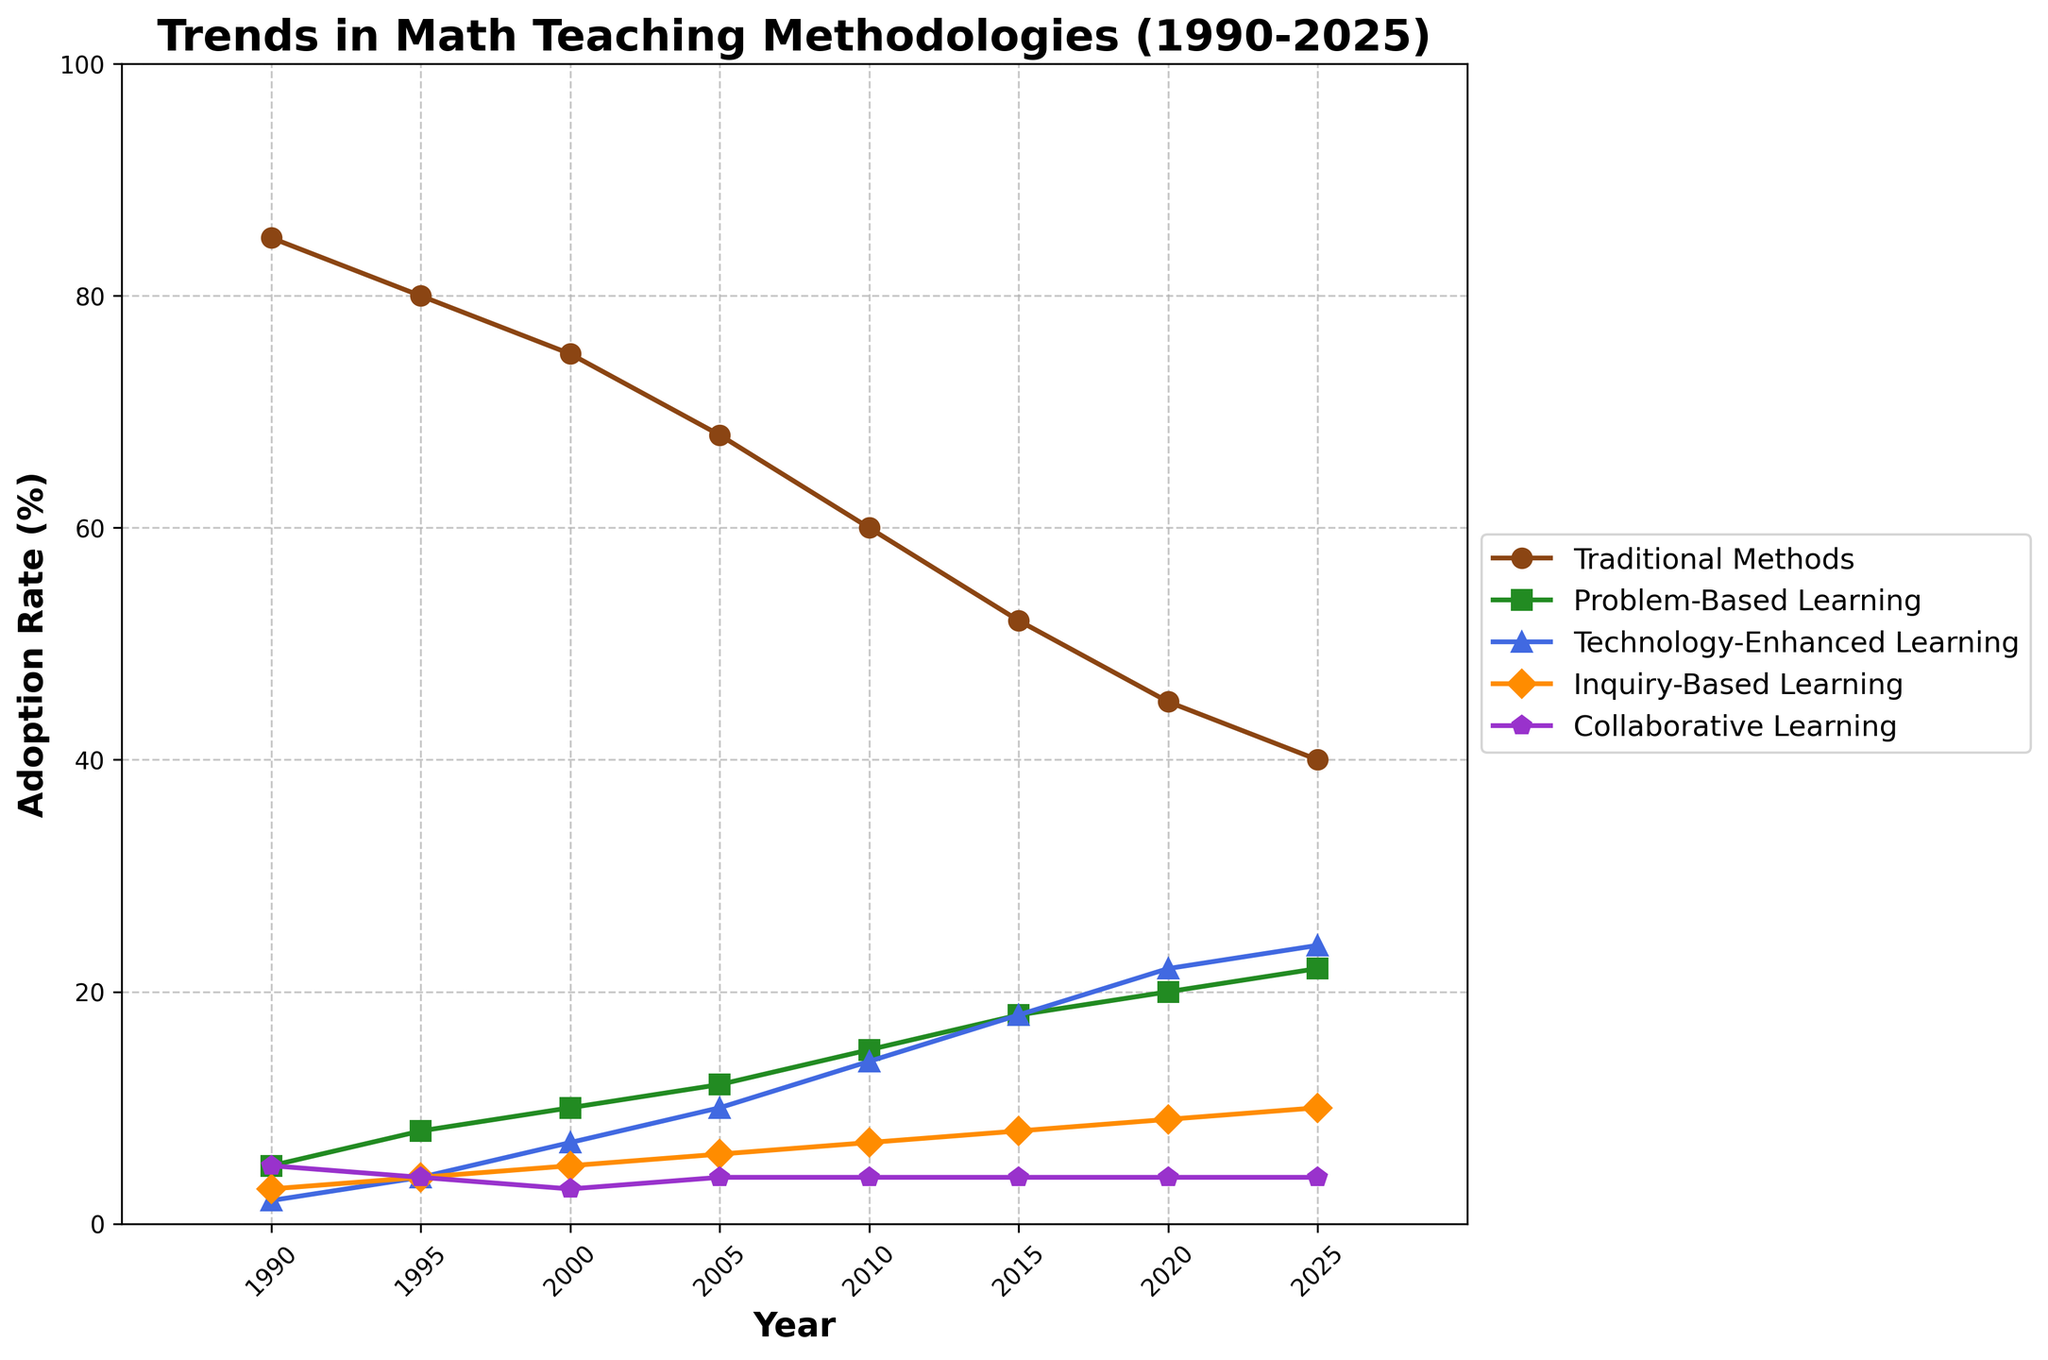What year did Traditional Methods have an adoption rate of 60%? Look at the line corresponding to Traditional Methods. Trace it to find the point where it intersects with the 60% adoption rate. Identify the year from the x-axis at this point.
Answer: 2010 Compare the adoption rates of Problem-Based Learning and Technology-Enhanced Learning in 2020. Which one is higher? Trace the lines for Problem-Based Learning and Technology-Enhanced Learning to the year 2020 on the x-axis. Compare the y-values (adoption rates) at this point for both methods.
Answer: Technology-Enhanced Learning What is the difference in adoption rates between Technology-Enhanced Learning and Inquiry-Based Learning in the year 2000? Find the y-values (adoption rates) for both Technology-Enhanced Learning and Inquiry-Based Learning in the year 2000 by tracing their lines to this year. Subtract the latter from the former.
Answer: 2 What is the average adoption rate of Traditional Methods from 1990 to 2025? Identify the adoption rates for Traditional Methods in each specified year: 1990 (85), 1995 (80), 2000 (75), 2005 (68), 2010 (60), 2015 (52), 2020 (45), 2025 (40). Add them together and divide by the number of data points (8).
Answer: 63.125 Which teaching methodology has a constant adoption rate from 2010 to 2025? Observe the lines representing each teaching methodology. Identify the one that remains at a constant value over the years from 2010 to 2025.
Answer: Collaborative Learning What is the trend in the adoption rate of Inquiry-Based Learning from 1990 to 2025? Follow the line representing Inquiry-Based Learning from 1990 to 2025. Note the direction of the line; whether it generally increases, decreases, or stays constant.
Answer: Increases In which year did Problem-Based Learning adoption rate surpass that of Inquiry-Based Learning? Trace the lines for Problem-Based Learning and Inquiry-Based Learning across the years. Identify the first point where the Problem-Based Learning's line is above Inquiry-Based Learning's line.
Answer: 2010 What is the total increase in the adoption rate of Technology-Enhanced Learning from 1990 to 2025? Identify the adoption rates of Technology-Enhanced Learning in 1990 (2%) and in 2025 (24%). Subtract the former from the latter to get the total increase.
Answer: 22 